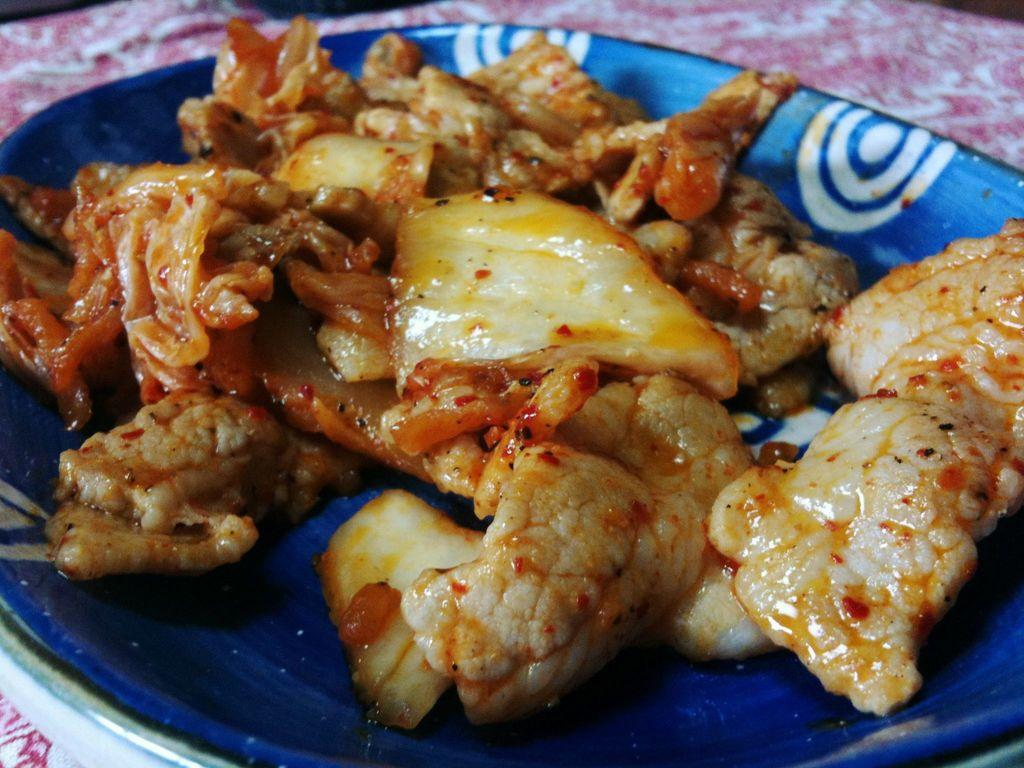What is on the plate that is visible in the image? There is food on a plate in the image. What color is the plate? The plate is blue. How many beans are on the plate in the image? There is no information about beans in the image, so we cannot determine the number of beans. 